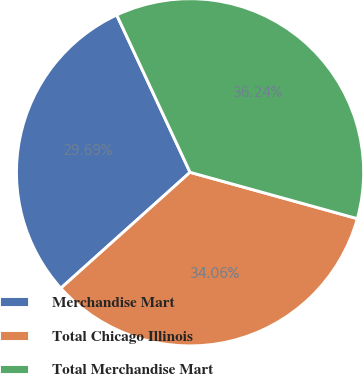<chart> <loc_0><loc_0><loc_500><loc_500><pie_chart><fcel>Merchandise Mart<fcel>Total Chicago Illinois<fcel>Total Merchandise Mart<nl><fcel>29.69%<fcel>34.06%<fcel>36.24%<nl></chart> 